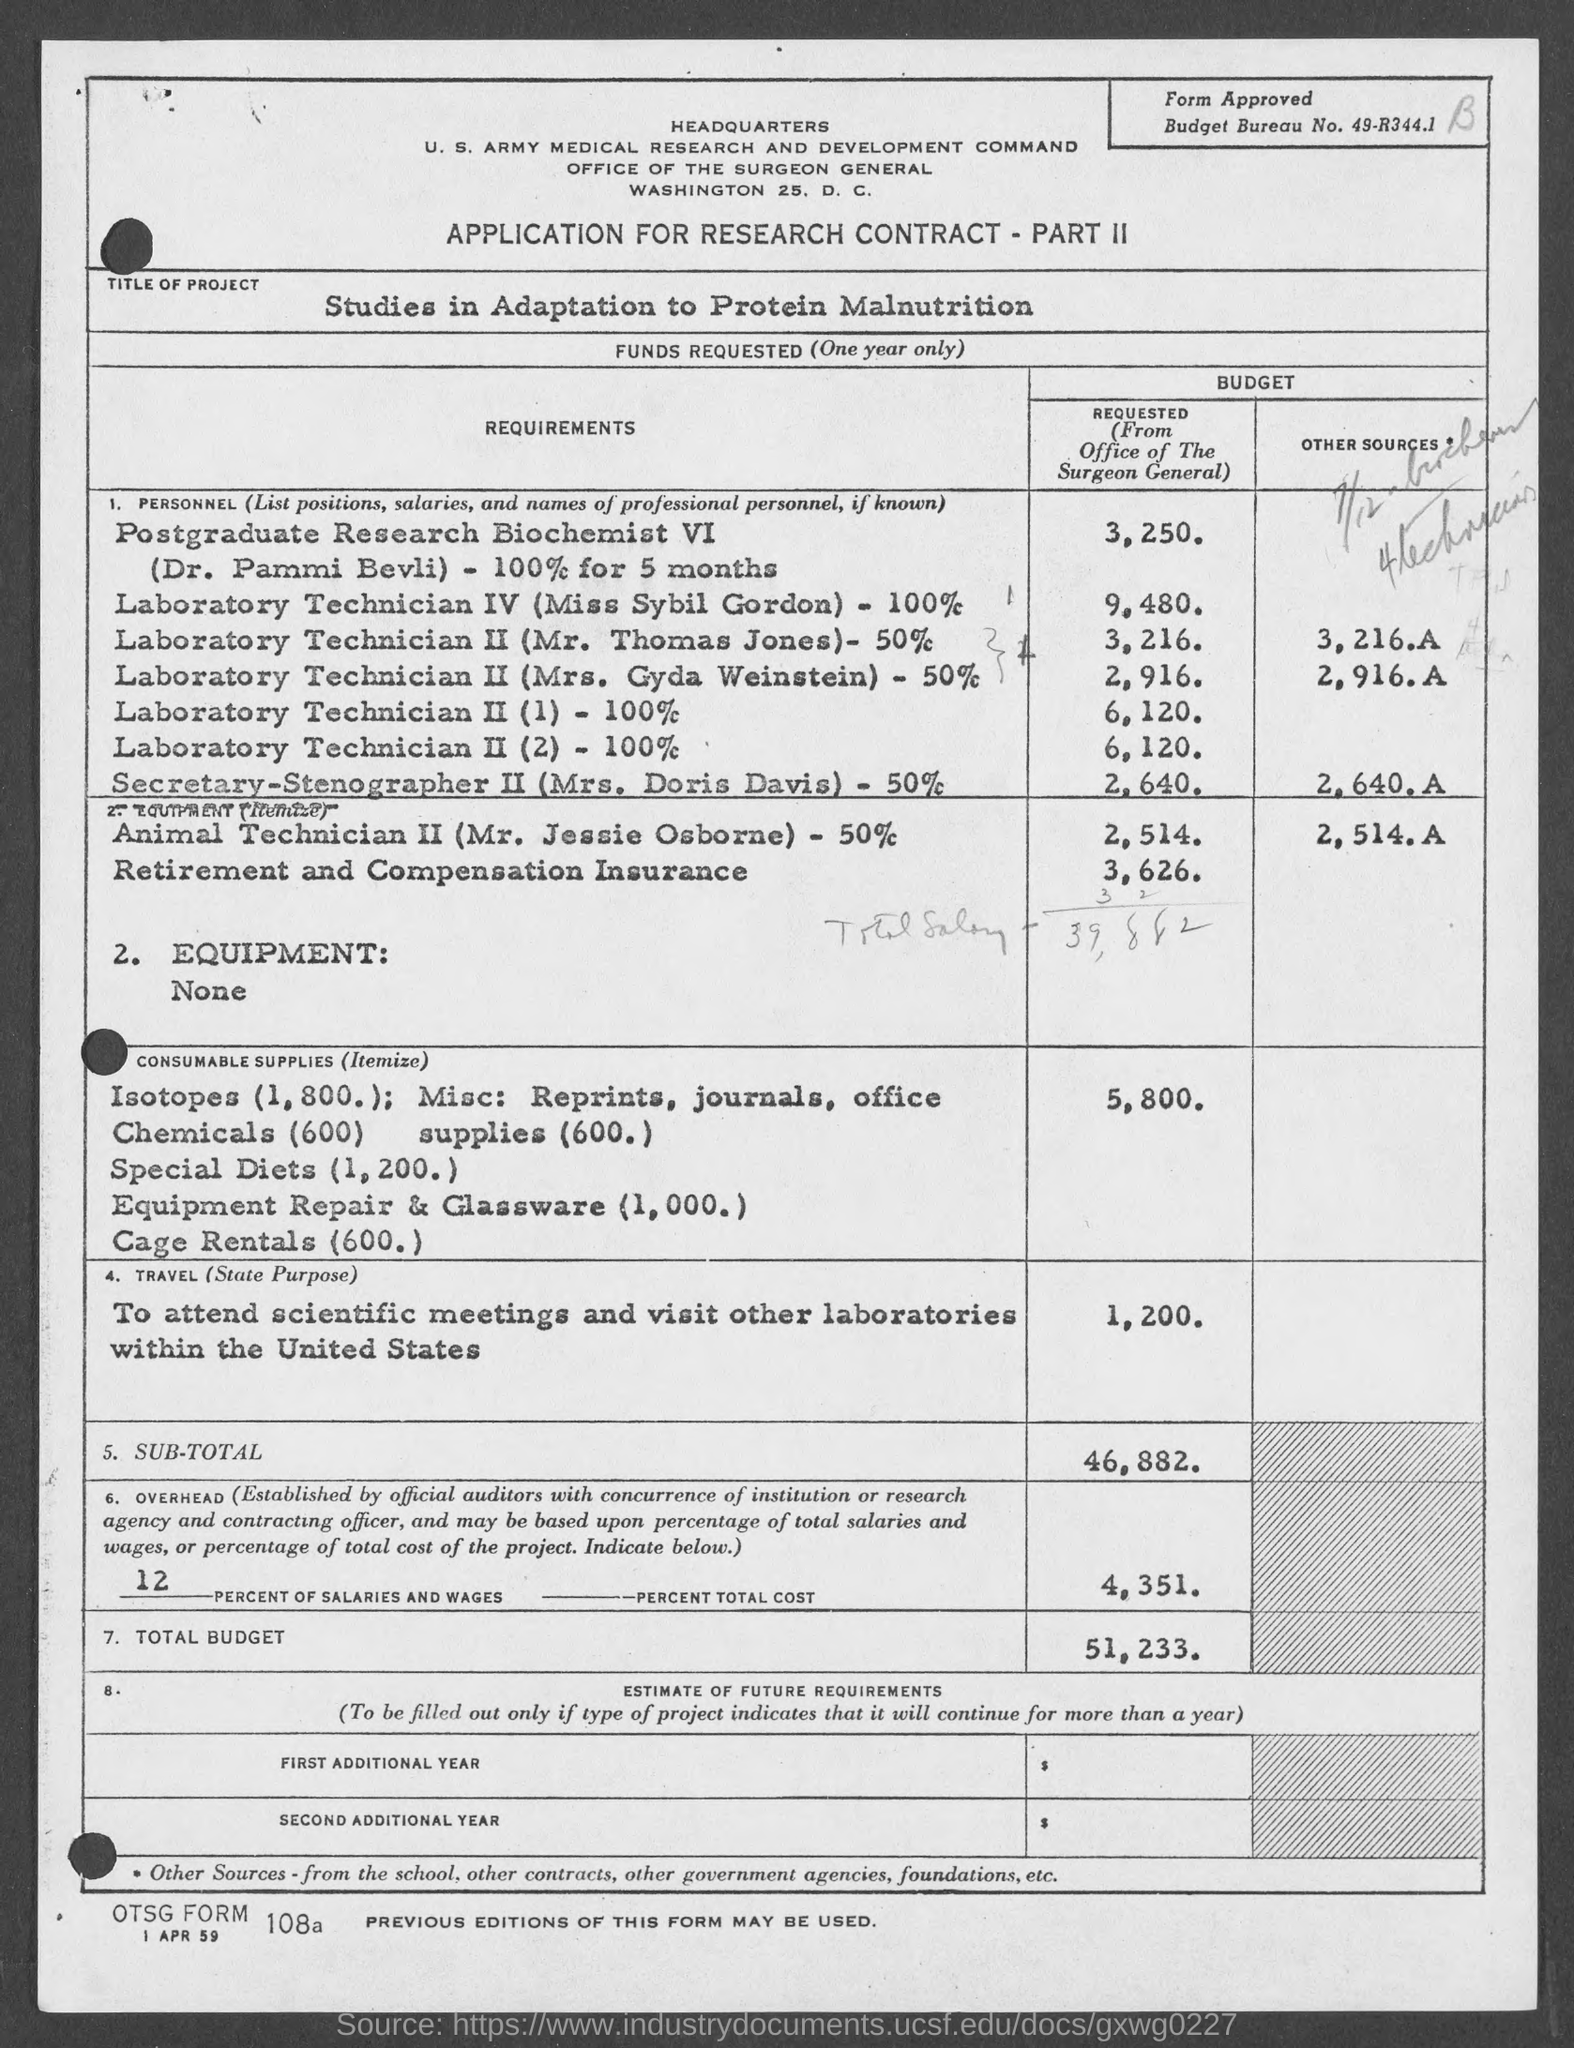What is the Budget Bureau No.?
Provide a succinct answer. 49-R344.1. What is the application about?
Offer a very short reply. APPLICATION FOR RESEARCH CONTRACT - PART II. What is the title of the project?
Give a very brief answer. Studies in Adaptation to Protein Malnutrition. 